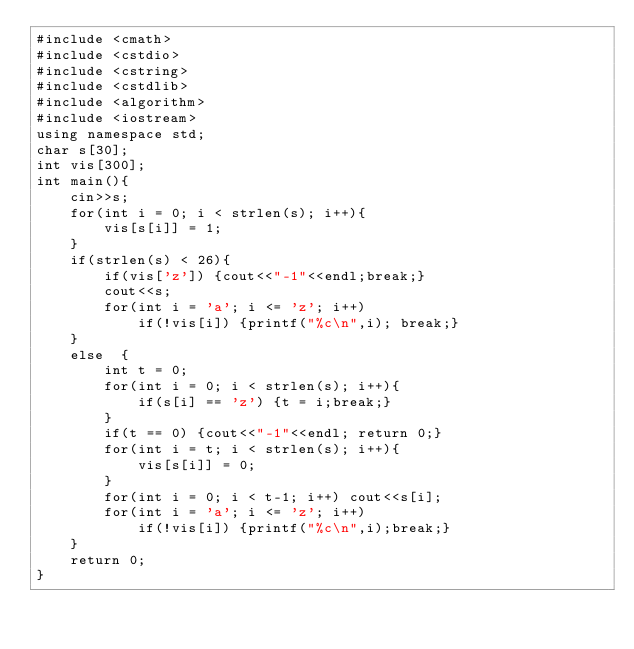<code> <loc_0><loc_0><loc_500><loc_500><_C++_>#include <cmath>
#include <cstdio>
#include <cstring>
#include <cstdlib>
#include <algorithm>
#include <iostream>
using namespace std;
char s[30];
int vis[300];
int main(){
	cin>>s;
	for(int i = 0; i < strlen(s); i++){
		vis[s[i]] = 1;
	}
	if(strlen(s) < 26){
		if(vis['z']) {cout<<"-1"<<endl;break;}
		cout<<s;
		for(int i = 'a'; i <= 'z'; i++)
			if(!vis[i]) {printf("%c\n",i); break;}
	}
	else  {
		int t = 0;
		for(int i = 0; i < strlen(s); i++){
			if(s[i] == 'z') {t = i;break;}
		}
		if(t == 0) {cout<<"-1"<<endl; return 0;}
		for(int i = t; i < strlen(s); i++){
			vis[s[i]] = 0;
		}
		for(int i = 0; i < t-1; i++) cout<<s[i];
		for(int i = 'a'; i <= 'z'; i++)
			if(!vis[i]) {printf("%c\n",i);break;}
	}
	return 0;
}</code> 